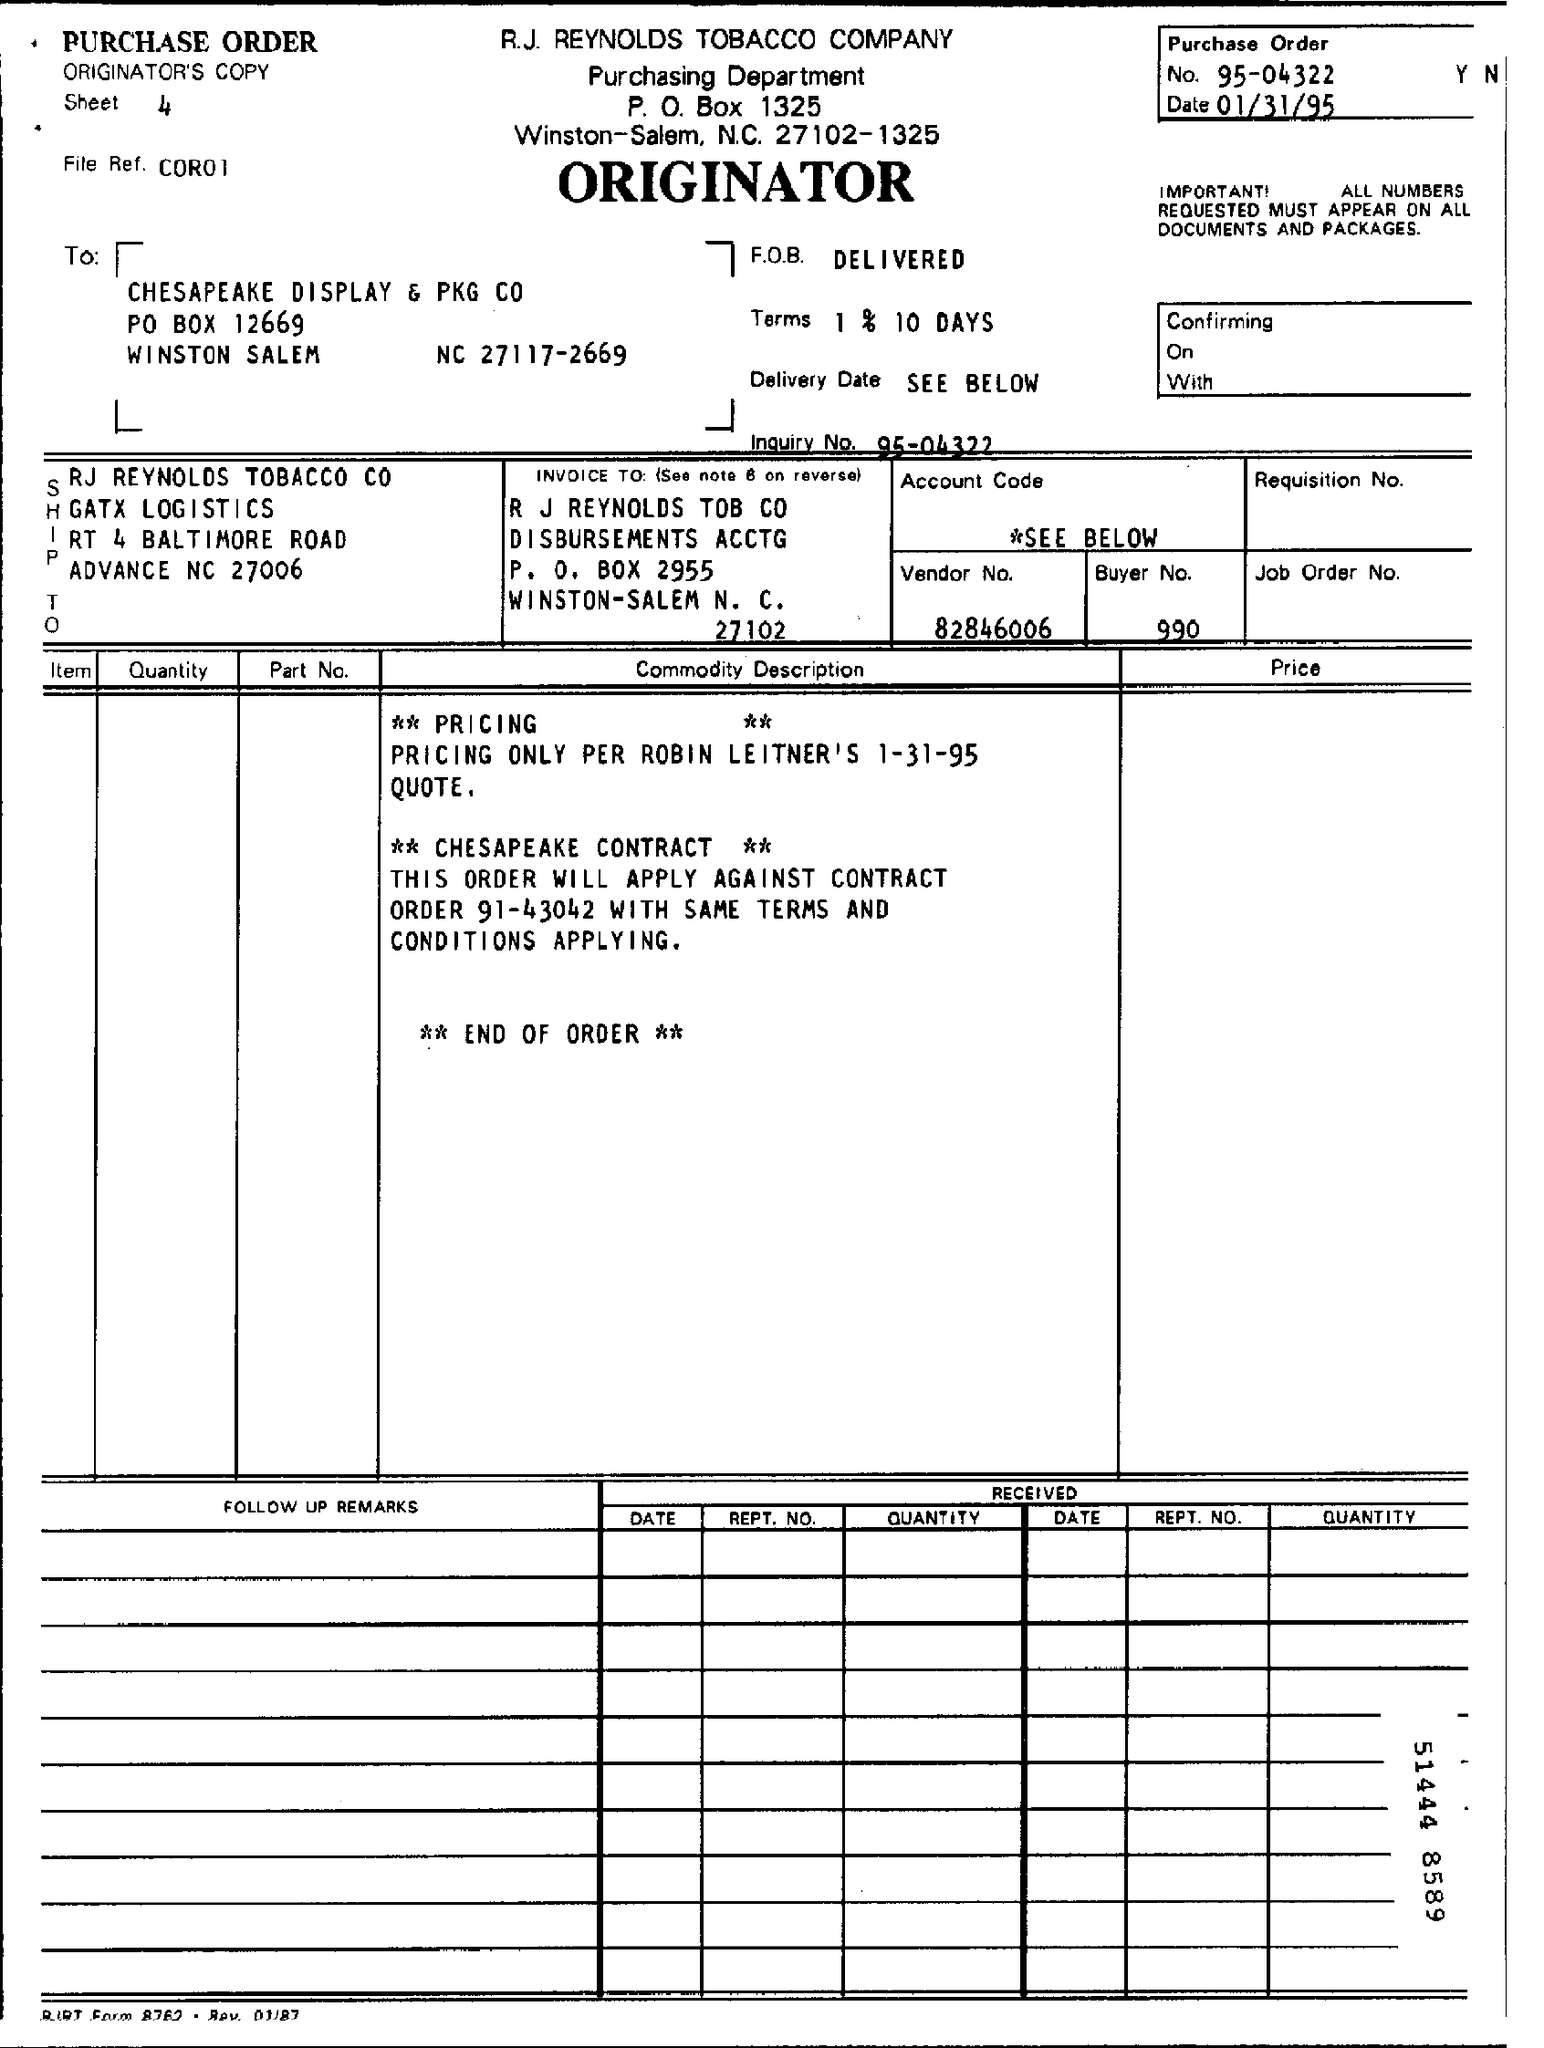What is the Company Name ?
Give a very brief answer. R.J. REYNOLDS TOBACCO COMPANY. What type of this Document ?
Provide a succinct answer. PURCHASE ORDER. What is the P.O Box Number of top of the document ?
Your response must be concise. 1325. What is the Purchase order number ?
Make the answer very short. 95-04322. What is the date mentioned in the top of the document ?
Offer a terse response. 01/31/95. What is the Vendor Number ?
Offer a very short reply. 82846006. What is the Buyer Number ?
Your answer should be compact. 990. What is the Sheet Number?
Give a very brief answer. 4. What is written in the F.O.B. Field ?
Offer a very short reply. DELIVERED. 